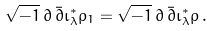Convert formula to latex. <formula><loc_0><loc_0><loc_500><loc_500>\sqrt { - 1 } \, \partial \, \bar { \partial } \iota ^ { * } _ { \lambda } \rho _ { 1 } = \sqrt { - 1 } \, \partial \, \bar { \partial } \iota ^ { * } _ { \lambda } \rho \, .</formula> 